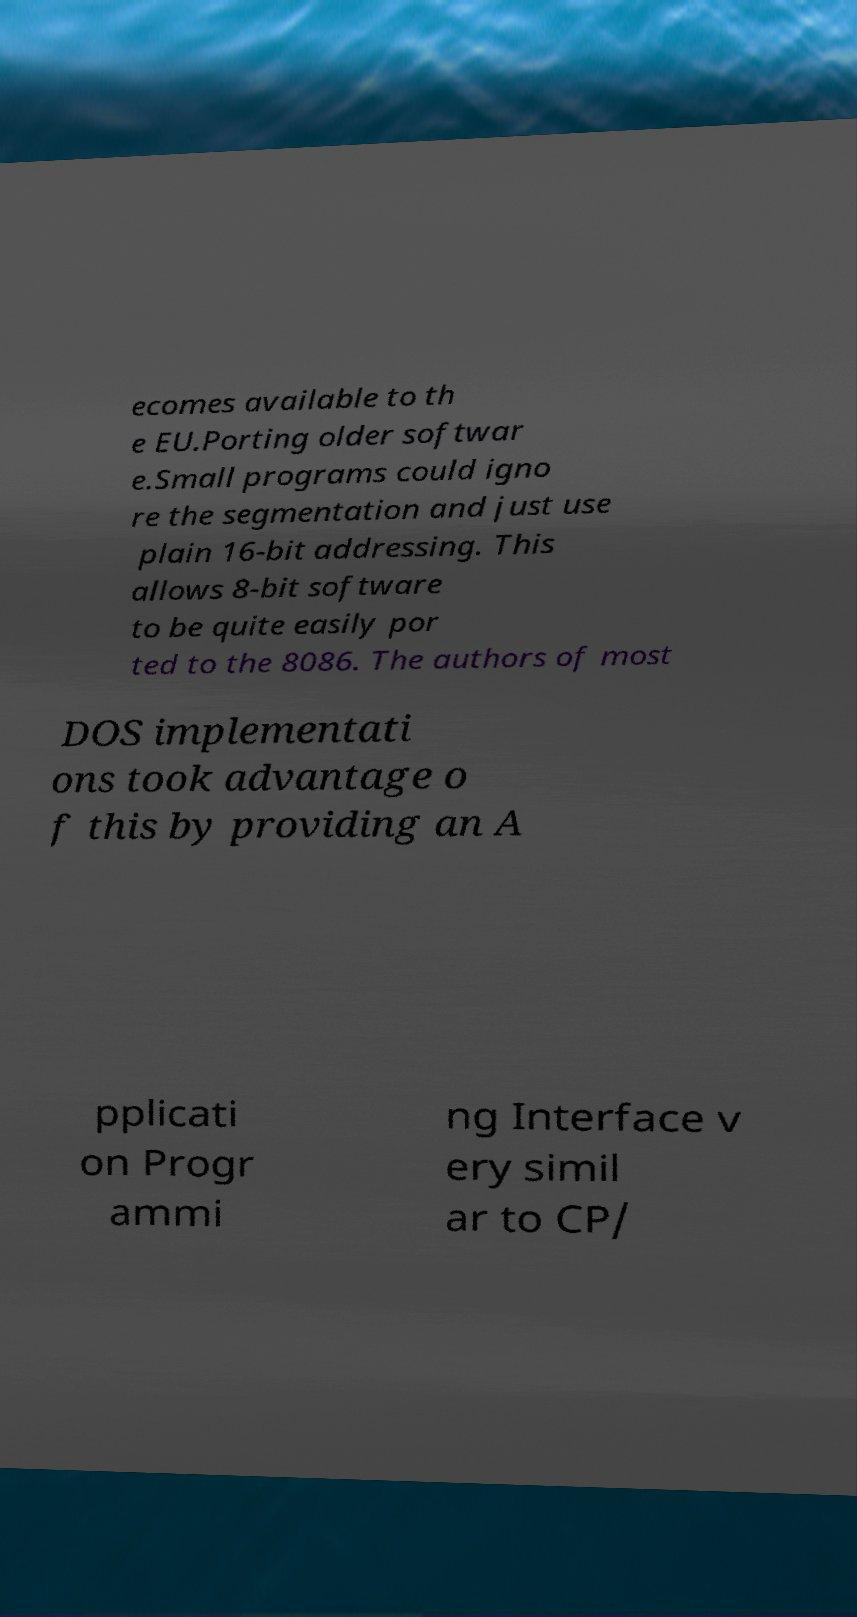For documentation purposes, I need the text within this image transcribed. Could you provide that? ecomes available to th e EU.Porting older softwar e.Small programs could igno re the segmentation and just use plain 16-bit addressing. This allows 8-bit software to be quite easily por ted to the 8086. The authors of most DOS implementati ons took advantage o f this by providing an A pplicati on Progr ammi ng Interface v ery simil ar to CP/ 